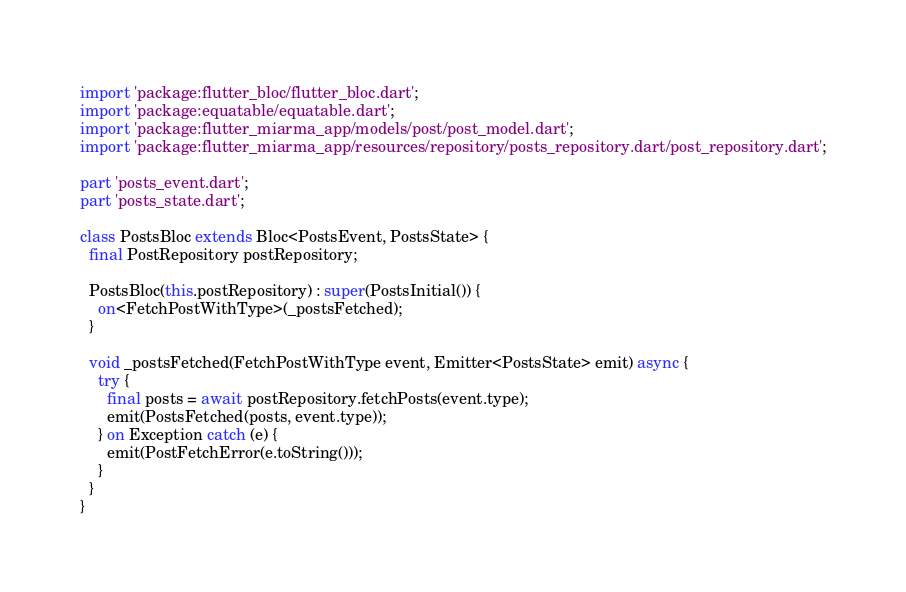Convert code to text. <code><loc_0><loc_0><loc_500><loc_500><_Dart_>import 'package:flutter_bloc/flutter_bloc.dart';
import 'package:equatable/equatable.dart';
import 'package:flutter_miarma_app/models/post/post_model.dart';
import 'package:flutter_miarma_app/resources/repository/posts_repository.dart/post_repository.dart';

part 'posts_event.dart';
part 'posts_state.dart';

class PostsBloc extends Bloc<PostsEvent, PostsState> {
  final PostRepository postRepository;

  PostsBloc(this.postRepository) : super(PostsInitial()) {
    on<FetchPostWithType>(_postsFetched);
  }

  void _postsFetched(FetchPostWithType event, Emitter<PostsState> emit) async {
    try {
      final posts = await postRepository.fetchPosts(event.type);
      emit(PostsFetched(posts, event.type));
    } on Exception catch (e) {
      emit(PostFetchError(e.toString()));
    }
  }
}
</code> 